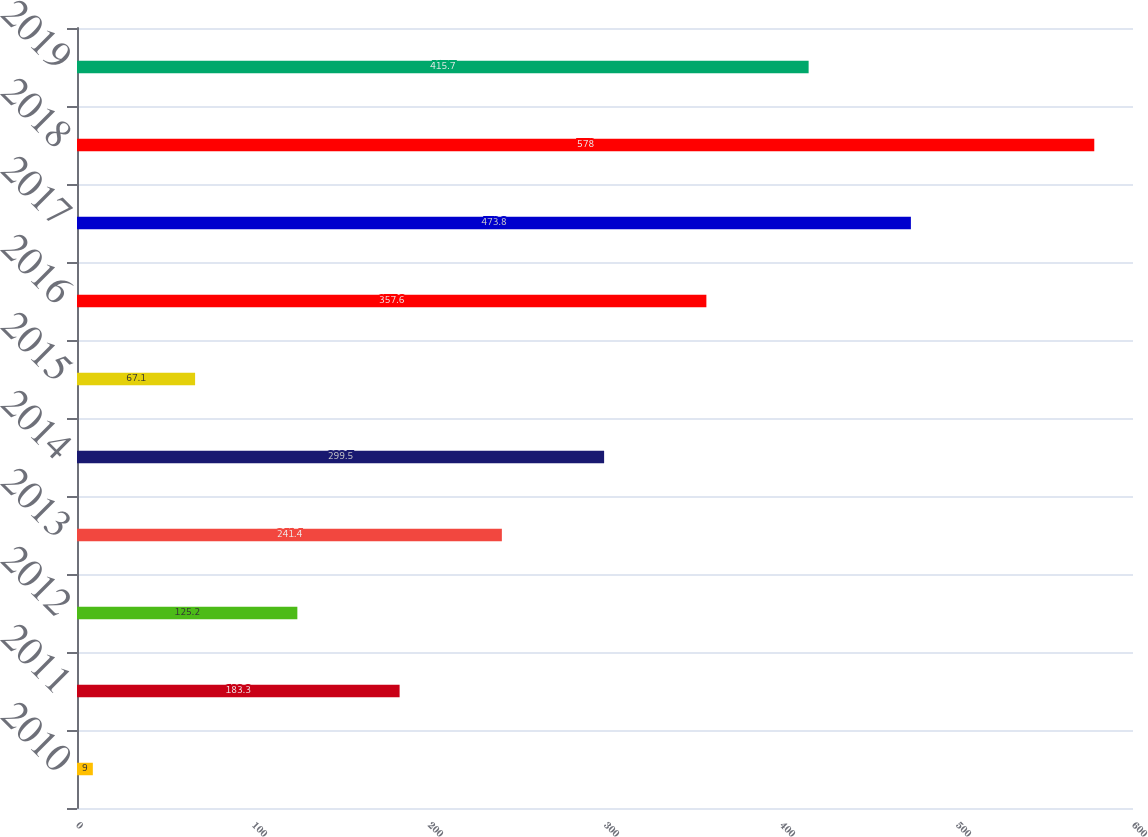Convert chart to OTSL. <chart><loc_0><loc_0><loc_500><loc_500><bar_chart><fcel>2010<fcel>2011<fcel>2012<fcel>2013<fcel>2014<fcel>2015<fcel>2016<fcel>2017<fcel>2018<fcel>2019<nl><fcel>9<fcel>183.3<fcel>125.2<fcel>241.4<fcel>299.5<fcel>67.1<fcel>357.6<fcel>473.8<fcel>578<fcel>415.7<nl></chart> 